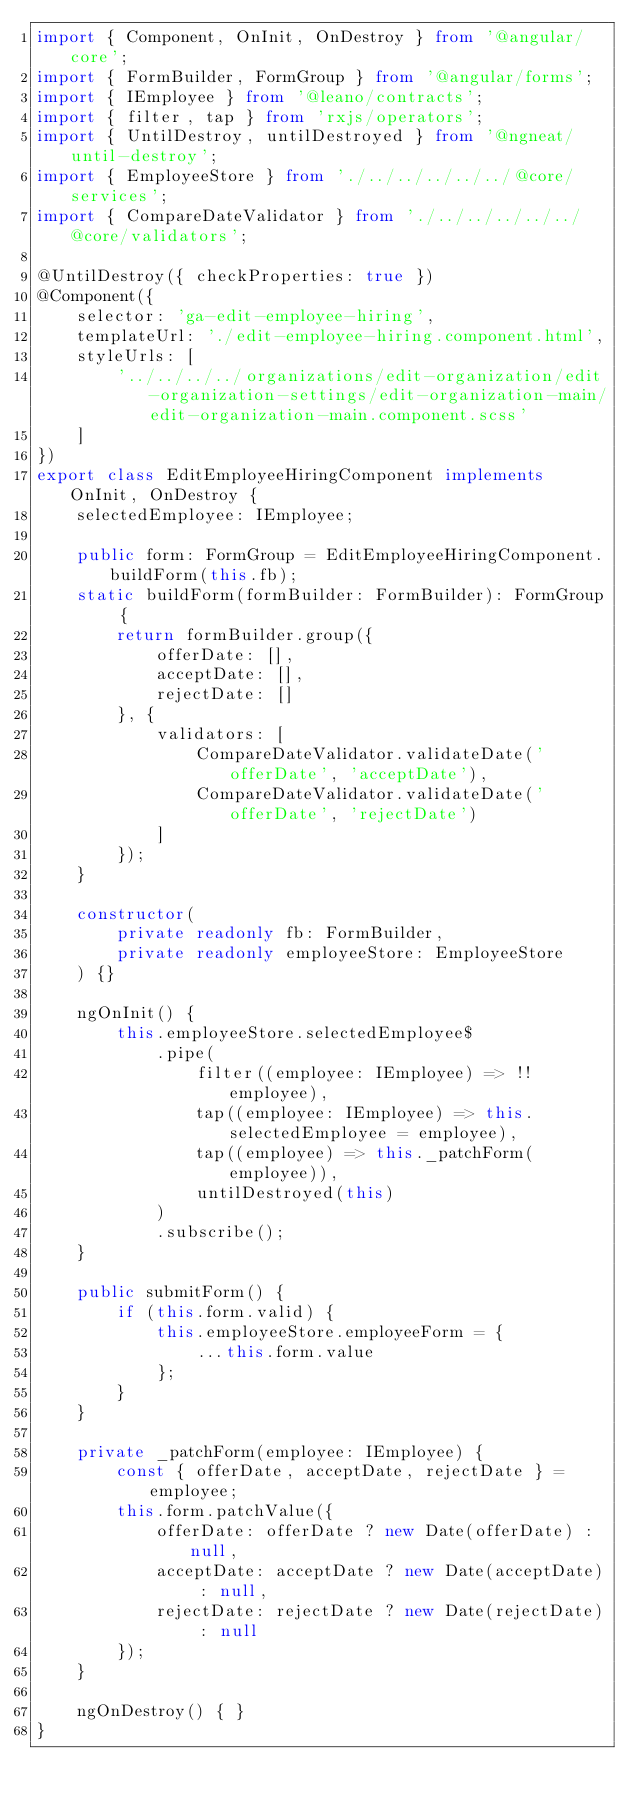Convert code to text. <code><loc_0><loc_0><loc_500><loc_500><_TypeScript_>import { Component, OnInit, OnDestroy } from '@angular/core';
import { FormBuilder, FormGroup } from '@angular/forms';
import { IEmployee } from '@leano/contracts';
import { filter, tap } from 'rxjs/operators';
import { UntilDestroy, untilDestroyed } from '@ngneat/until-destroy';
import { EmployeeStore } from './../../../../../@core/services';
import { CompareDateValidator } from './../../../../../@core/validators';

@UntilDestroy({ checkProperties: true })
@Component({
	selector: 'ga-edit-employee-hiring',
	templateUrl: './edit-employee-hiring.component.html',
	styleUrls: [
		'../../../../organizations/edit-organization/edit-organization-settings/edit-organization-main/edit-organization-main.component.scss'
	]
})
export class EditEmployeeHiringComponent implements OnInit, OnDestroy {
	selectedEmployee: IEmployee;

	public form: FormGroup = EditEmployeeHiringComponent.buildForm(this.fb);
	static buildForm(formBuilder: FormBuilder): FormGroup {
		return formBuilder.group({
			offerDate: [],
			acceptDate: [],
			rejectDate: []
		}, { 
			validators: [
				CompareDateValidator.validateDate('offerDate', 'acceptDate'),
				CompareDateValidator.validateDate('offerDate', 'rejectDate')
			]
		});
	}

	constructor(
		private readonly fb: FormBuilder,
		private readonly employeeStore: EmployeeStore
	) {}

	ngOnInit() {
		this.employeeStore.selectedEmployee$
			.pipe(
				filter((employee: IEmployee) => !!employee),
				tap((employee: IEmployee) => this.selectedEmployee = employee),
				tap((employee) => this._patchForm(employee)),
				untilDestroyed(this)
			)
			.subscribe();
	}

	public submitForm() {
		if (this.form.valid) {
			this.employeeStore.employeeForm = {
				...this.form.value
			};
		}
	}

	private _patchForm(employee: IEmployee) {
		const { offerDate, acceptDate, rejectDate } = employee;
		this.form.patchValue({ 
			offerDate: offerDate ? new Date(offerDate) : null,
			acceptDate: acceptDate ? new Date(acceptDate) : null,
			rejectDate: rejectDate ? new Date(rejectDate) : null
		});
	}

	ngOnDestroy() { }
}
</code> 